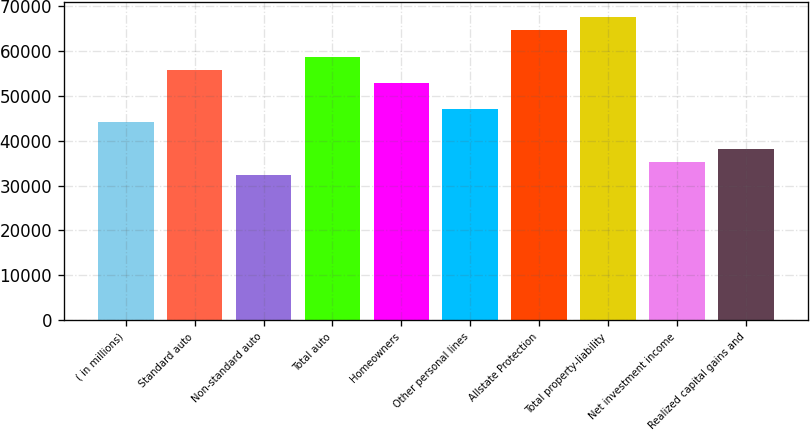Convert chart to OTSL. <chart><loc_0><loc_0><loc_500><loc_500><bar_chart><fcel>( in millions)<fcel>Standard auto<fcel>Non-standard auto<fcel>Total auto<fcel>Homeowners<fcel>Other personal lines<fcel>Allstate Protection<fcel>Total property-liability<fcel>Net investment income<fcel>Realized capital gains and<nl><fcel>44086<fcel>55839.6<fcel>32332.4<fcel>58778<fcel>52901.2<fcel>47024.4<fcel>64654.8<fcel>67593.2<fcel>35270.8<fcel>38209.2<nl></chart> 